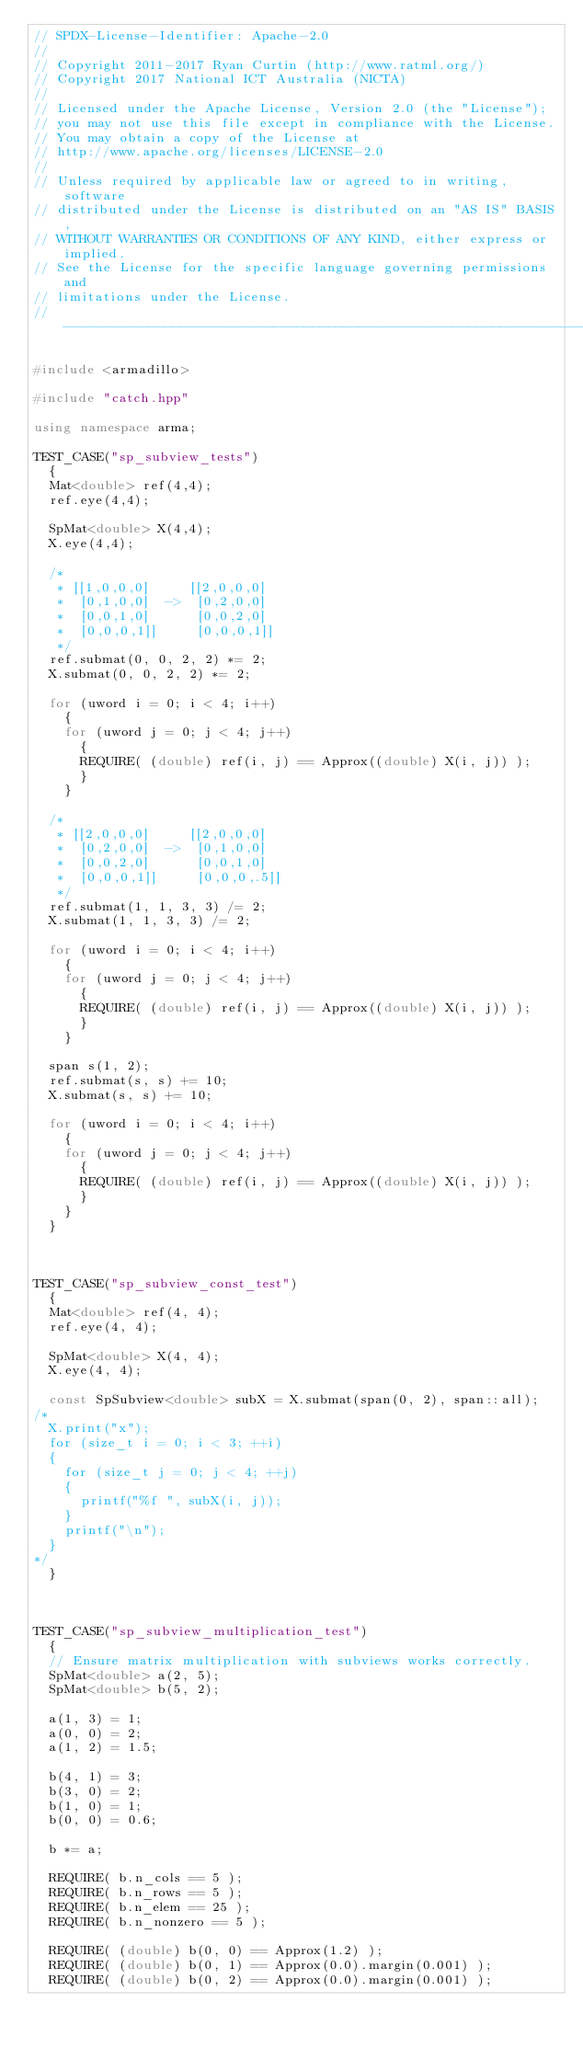Convert code to text. <code><loc_0><loc_0><loc_500><loc_500><_C++_>// SPDX-License-Identifier: Apache-2.0
// 
// Copyright 2011-2017 Ryan Curtin (http://www.ratml.org/)
// Copyright 2017 National ICT Australia (NICTA)
//
// Licensed under the Apache License, Version 2.0 (the "License");
// you may not use this file except in compliance with the License.
// You may obtain a copy of the License at
// http://www.apache.org/licenses/LICENSE-2.0
//
// Unless required by applicable law or agreed to in writing, software
// distributed under the License is distributed on an "AS IS" BASIS,
// WITHOUT WARRANTIES OR CONDITIONS OF ANY KIND, either express or implied.
// See the License for the specific language governing permissions and
// limitations under the License.
// ------------------------------------------------------------------------

#include <armadillo>

#include "catch.hpp"

using namespace arma;

TEST_CASE("sp_subview_tests")
  {
  Mat<double> ref(4,4);
  ref.eye(4,4);

  SpMat<double> X(4,4);
  X.eye(4,4);

  /*
   * [[1,0,0,0]     [[2,0,0,0]
   *  [0,1,0,0]  ->  [0,2,0,0]
   *  [0,0,1,0]      [0,0,2,0]
   *  [0,0,0,1]]     [0,0,0,1]]
   */
  ref.submat(0, 0, 2, 2) *= 2;
  X.submat(0, 0, 2, 2) *= 2;

  for (uword i = 0; i < 4; i++)
    {
    for (uword j = 0; j < 4; j++)
      {
      REQUIRE( (double) ref(i, j) == Approx((double) X(i, j)) );
      }
    }

  /*
   * [[2,0,0,0]     [[2,0,0,0]
   *  [0,2,0,0]  ->  [0,1,0,0]
   *  [0,0,2,0]      [0,0,1,0]
   *  [0,0,0,1]]     [0,0,0,.5]]
   */
  ref.submat(1, 1, 3, 3) /= 2;
  X.submat(1, 1, 3, 3) /= 2;

  for (uword i = 0; i < 4; i++)
    {
    for (uword j = 0; j < 4; j++)
      {
      REQUIRE( (double) ref(i, j) == Approx((double) X(i, j)) );
      }
    }

  span s(1, 2);
  ref.submat(s, s) += 10;
  X.submat(s, s) += 10;

  for (uword i = 0; i < 4; i++)
    {
    for (uword j = 0; j < 4; j++)
      {
      REQUIRE( (double) ref(i, j) == Approx((double) X(i, j)) );
      }
    }
  }



TEST_CASE("sp_subview_const_test")
  {
  Mat<double> ref(4, 4);
  ref.eye(4, 4);

  SpMat<double> X(4, 4);
  X.eye(4, 4);

  const SpSubview<double> subX = X.submat(span(0, 2), span::all);
/*
  X.print("x");
  for (size_t i = 0; i < 3; ++i)
  {
    for (size_t j = 0; j < 4; ++j)
    {
      printf("%f ", subX(i, j));
    }
    printf("\n");
  }
*/
  }



TEST_CASE("sp_subview_multiplication_test")
  {
  // Ensure matrix multiplication with subviews works correctly.
  SpMat<double> a(2, 5);
  SpMat<double> b(5, 2);

  a(1, 3) = 1;
  a(0, 0) = 2;
  a(1, 2) = 1.5;

  b(4, 1) = 3;
  b(3, 0) = 2;
  b(1, 0) = 1;
  b(0, 0) = 0.6;

  b *= a;

  REQUIRE( b.n_cols == 5 );
  REQUIRE( b.n_rows == 5 );
  REQUIRE( b.n_elem == 25 );
  REQUIRE( b.n_nonzero == 5 );

  REQUIRE( (double) b(0, 0) == Approx(1.2) );
  REQUIRE( (double) b(0, 1) == Approx(0.0).margin(0.001) );
  REQUIRE( (double) b(0, 2) == Approx(0.0).margin(0.001) );</code> 